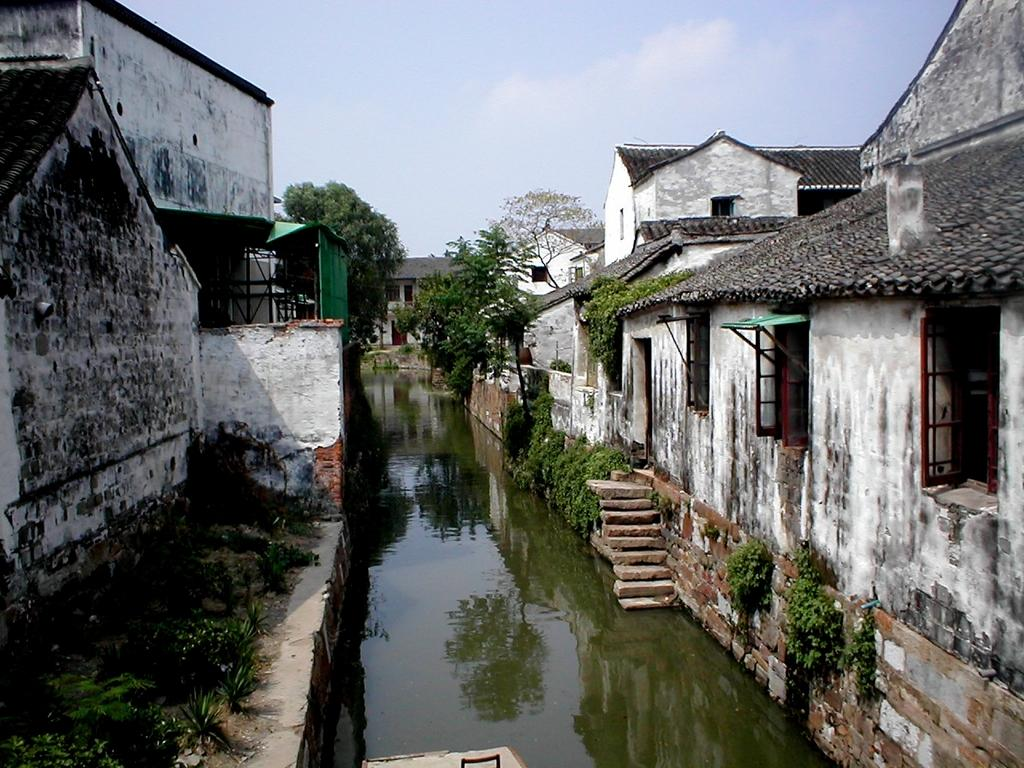What is the setting of the image? The image is an outside view. What is the main feature in the middle of the image? There is a lake in the middle of the image. What can be seen on both sides of the lake? There are many houses and trees on both sides of the lake. What is visible at the top of the image? The sky is visible at the top of the image. How many cakes are being served by the son in the image? There is no son or cakes present in the image. What type of insect can be seen flying near the trees in the image? There is no insect visible in the image; it only features a lake, houses, trees, and the sky. 